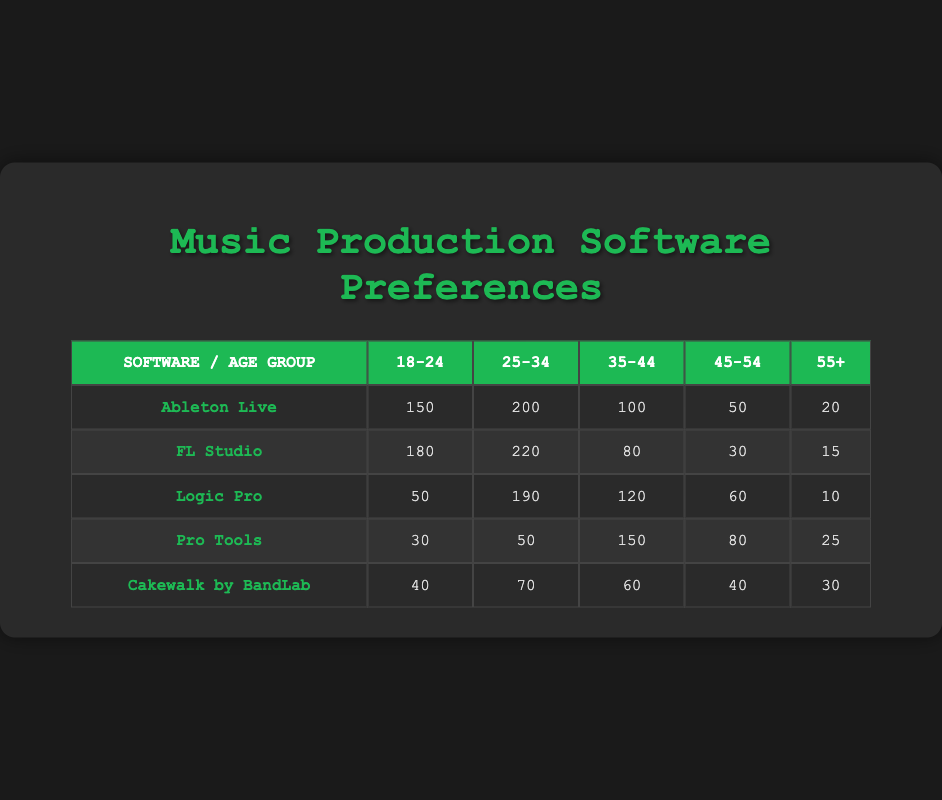What is the most preferred software among the 25-34 age group? For the 25-34 age group, the preferences are: Ableton Live (200), FL Studio (220), Logic Pro (190), Pro Tools (50), and Cakewalk by BandLab (70). The highest value is for FL Studio, which has 220 users.
Answer: FL Studio How many musicians aged 55 and older prefer Logic Pro? According to the table, the number of musicians aged 55 and older who prefer Logic Pro is 10. This value is retrieved directly from the corresponding row and column for Logic Pro and the 55+ age group.
Answer: 10 Which age group shows the highest preference for Ableton Live? Reviewing the table, we see the preferences for Ableton Live across different age groups: 150 (18-24), 200 (25-34), 100 (35-44), 50 (45-54), and 20 (55+). The highest value is 200, which corresponds to the 25-34 age group.
Answer: 25-34 What is the total preference for Pro Tools across all age groups? To calculate the total preference for Pro Tools, add the values from each age group: 30 (18-24) + 50 (25-34) + 150 (35-44) + 80 (45-54) + 25 (55+) = 335. Therefore, the total preference for Pro Tools is 335.
Answer: 335 Is the preference for FL Studio greater than that for Logic Pro in the 35-44 age group? The preferences for each software in the 35-44 age group are: FL Studio (80) and Logic Pro (120). Since 120 is greater than 80, we conclude that the preference for Logic Pro is greater than that for FL Studio in this age group.
Answer: No What is the average number of users for Cakewalk by BandLab across all age groups? The users for Cakewalk by BandLab in each age group are 40 (18-24), 70 (25-34), 60 (35-44), 40 (45-54), and 30 (55+). The sum is 40 + 70 + 60 + 40 + 30 = 240. There are 5 age groups; hence, the average is 240/5 = 48.
Answer: 48 In which age group does Pro Tools have the lowest preference? The preferences for Pro Tools across the age groups are: 30 (18-24), 50 (25-34), 150 (35-44), 80 (45-54), and 25 (55+). The lowest value, 25, corresponds to the 55+ age group.
Answer: 55+ How many more musicians aged 18-24 prefer FL Studio compared to Logic Pro? The number of musicians aged 18-24 who prefer FL Studio is 180, while those who prefer Logic Pro is 50. To find the difference: 180 - 50 = 130. Thus, 130 more musicians aged 18-24 prefer FL Studio over Logic Pro.
Answer: 130 